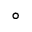Convert formula to latex. <formula><loc_0><loc_0><loc_500><loc_500>^ { \circ }</formula> 